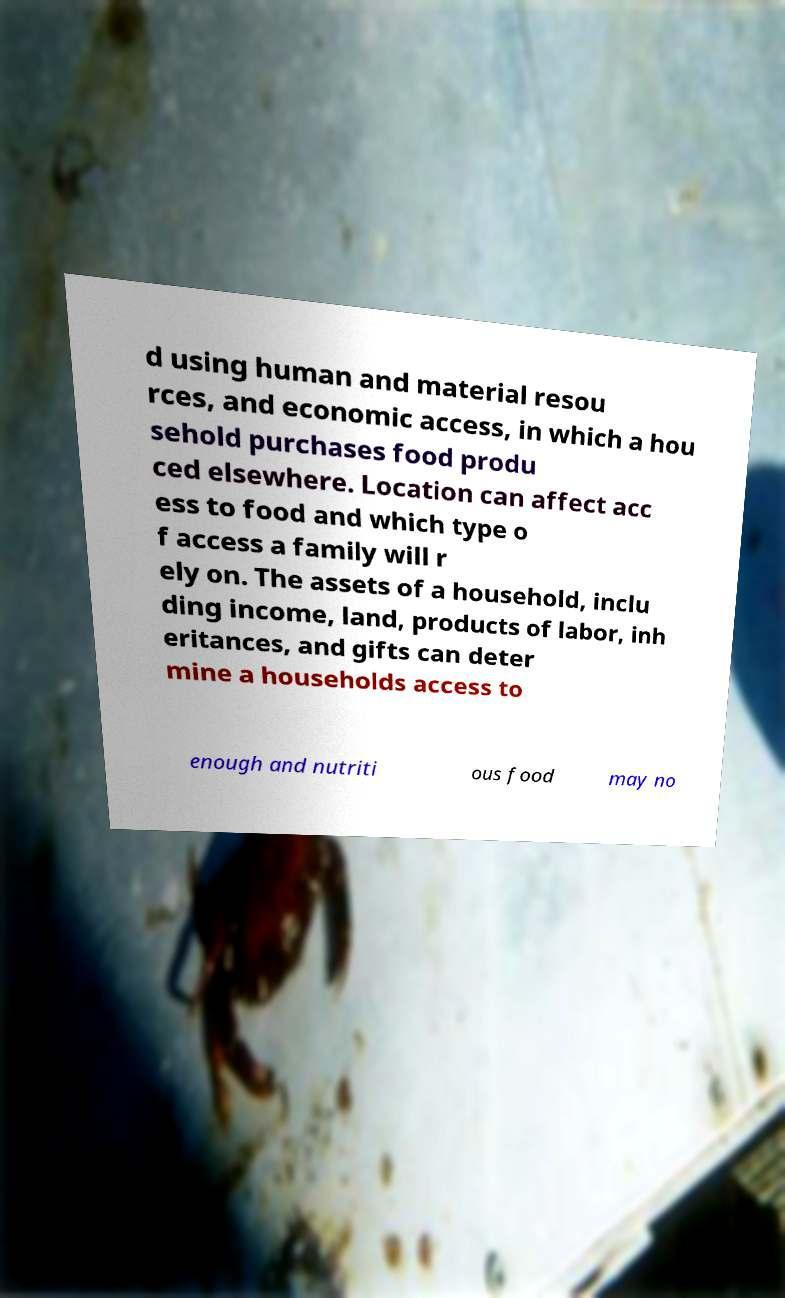For documentation purposes, I need the text within this image transcribed. Could you provide that? d using human and material resou rces, and economic access, in which a hou sehold purchases food produ ced elsewhere. Location can affect acc ess to food and which type o f access a family will r ely on. The assets of a household, inclu ding income, land, products of labor, inh eritances, and gifts can deter mine a households access to enough and nutriti ous food may no 